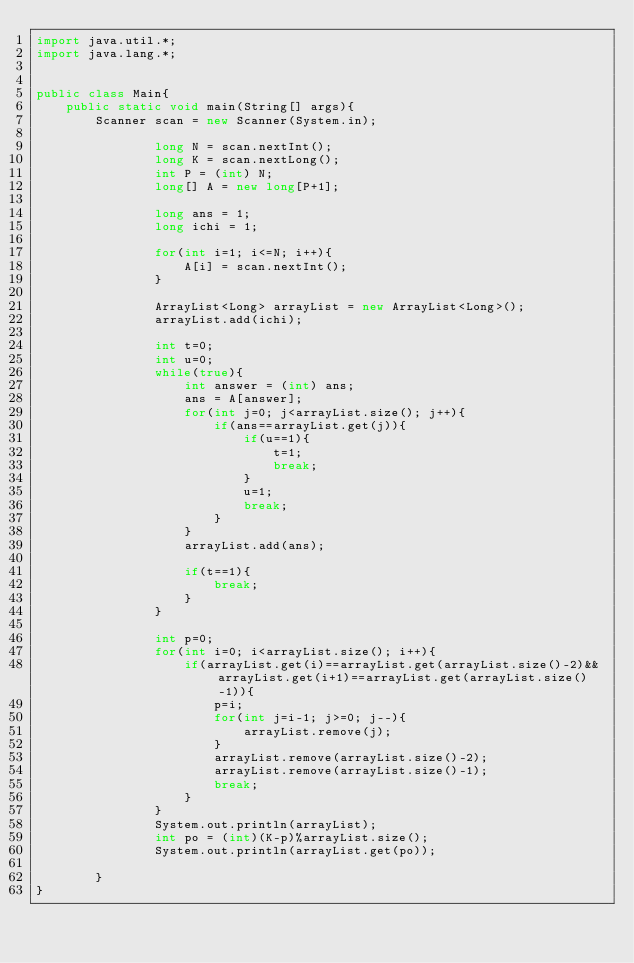<code> <loc_0><loc_0><loc_500><loc_500><_Java_>import java.util.*; 
import java.lang.*; 


public class Main{
	public static void main(String[] args){
		Scanner scan = new Scanner(System.in);
                
                long N = scan.nextInt();
                long K = scan.nextLong();
                int P = (int) N;
                long[] A = new long[P+1];
                
                long ans = 1;
                long ichi = 1;
                
                for(int i=1; i<=N; i++){
                    A[i] = scan.nextInt();
                }

                ArrayList<Long> arrayList = new ArrayList<Long>();
                arrayList.add(ichi);
                
                int t=0;
                int u=0;
                while(true){
                    int answer = (int) ans;
                    ans = A[answer];
                    for(int j=0; j<arrayList.size(); j++){
                        if(ans==arrayList.get(j)){
                            if(u==1){
                                t=1;
                                break;
                            }
                            u=1;
                            break;
                        }
                    }
                    arrayList.add(ans);
        
                    if(t==1){
                        break;
                    }
                }
                
                int p=0;
                for(int i=0; i<arrayList.size(); i++){
                    if(arrayList.get(i)==arrayList.get(arrayList.size()-2)&&arrayList.get(i+1)==arrayList.get(arrayList.size()-1)){
                        p=i;
                        for(int j=i-1; j>=0; j--){
                            arrayList.remove(j);
                        }
                        arrayList.remove(arrayList.size()-2);
                        arrayList.remove(arrayList.size()-1);
                        break;
                    }
                }
                System.out.println(arrayList);
                int po = (int)(K-p)%arrayList.size();
                System.out.println(arrayList.get(po));
              
        }
}
</code> 